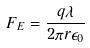<formula> <loc_0><loc_0><loc_500><loc_500>F _ { E } = \frac { q \lambda } { 2 \pi r \epsilon _ { 0 } }</formula> 